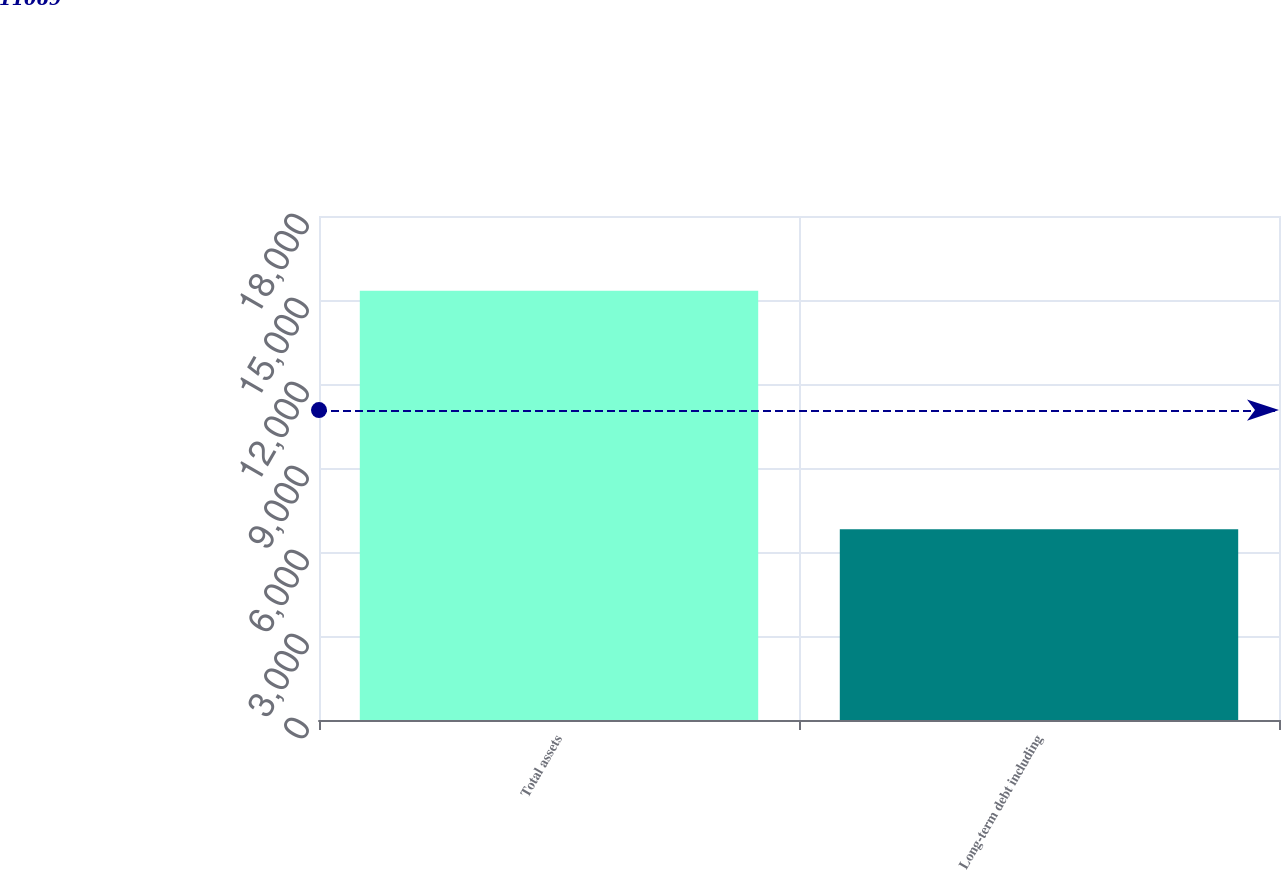Convert chart to OTSL. <chart><loc_0><loc_0><loc_500><loc_500><bar_chart><fcel>Total assets<fcel>Long-term debt including<nl><fcel>15326<fcel>6812<nl></chart> 